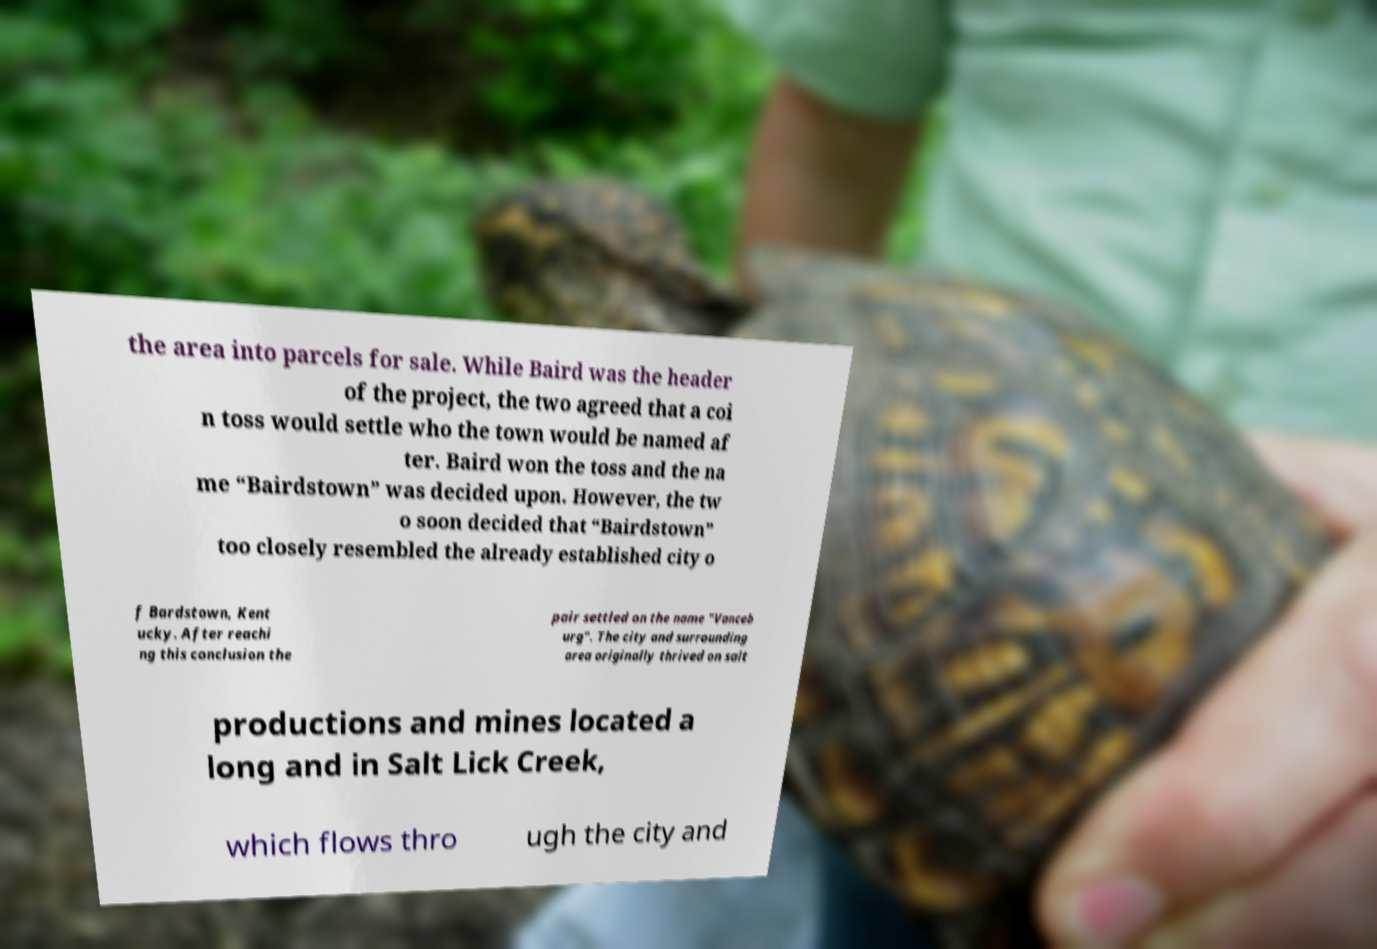There's text embedded in this image that I need extracted. Can you transcribe it verbatim? the area into parcels for sale. While Baird was the header of the project, the two agreed that a coi n toss would settle who the town would be named af ter. Baird won the toss and the na me “Bairdstown” was decided upon. However, the tw o soon decided that “Bairdstown” too closely resembled the already established city o f Bardstown, Kent ucky. After reachi ng this conclusion the pair settled on the name "Vanceb urg". The city and surrounding area originally thrived on salt productions and mines located a long and in Salt Lick Creek, which flows thro ugh the city and 